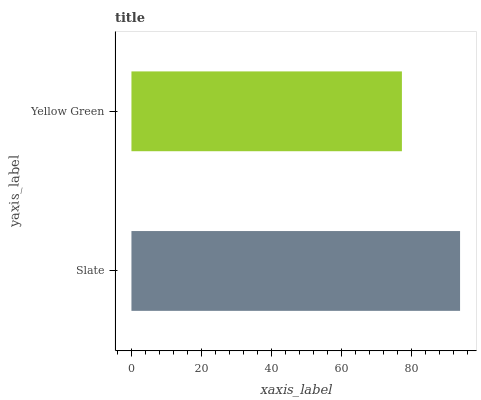Is Yellow Green the minimum?
Answer yes or no. Yes. Is Slate the maximum?
Answer yes or no. Yes. Is Yellow Green the maximum?
Answer yes or no. No. Is Slate greater than Yellow Green?
Answer yes or no. Yes. Is Yellow Green less than Slate?
Answer yes or no. Yes. Is Yellow Green greater than Slate?
Answer yes or no. No. Is Slate less than Yellow Green?
Answer yes or no. No. Is Slate the high median?
Answer yes or no. Yes. Is Yellow Green the low median?
Answer yes or no. Yes. Is Yellow Green the high median?
Answer yes or no. No. Is Slate the low median?
Answer yes or no. No. 